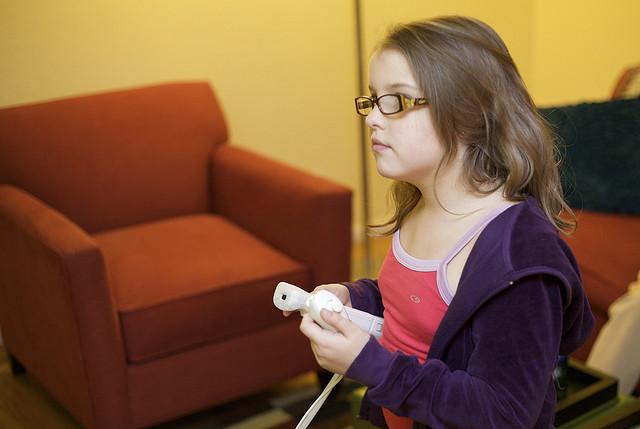What game system is she playing?
Be succinct. Wii. What color jacket is the girl wearing?
Answer briefly. Purple. What is the woman holding in her left hand?
Answer briefly. Wii controller. Is this girl under the age of 15?
Be succinct. Yes. How many young girls?
Give a very brief answer. 1. What color is the girl's shirt?
Write a very short answer. Pink. 